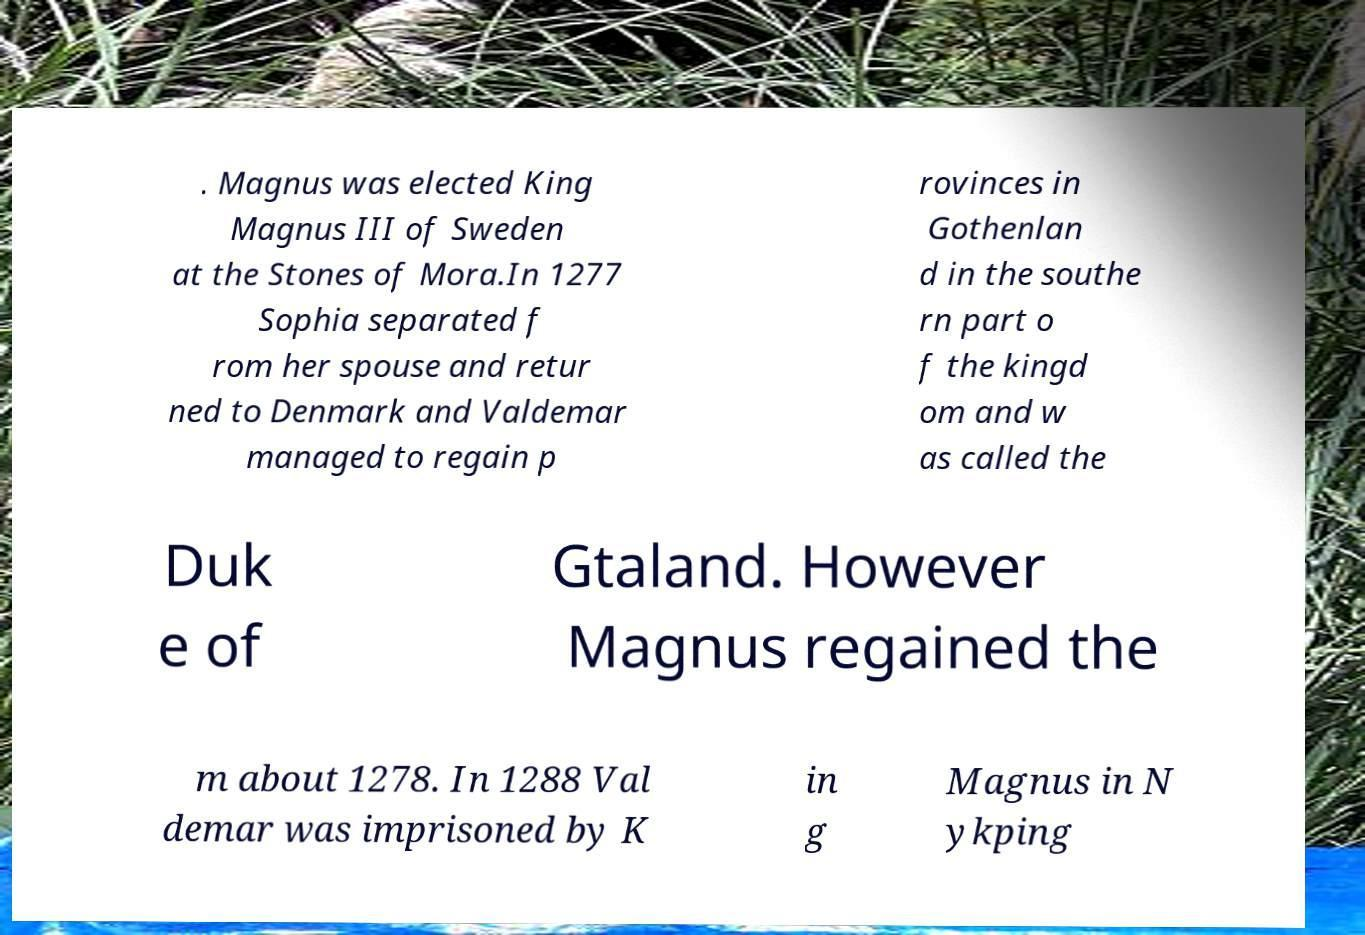Can you read and provide the text displayed in the image?This photo seems to have some interesting text. Can you extract and type it out for me? . Magnus was elected King Magnus III of Sweden at the Stones of Mora.In 1277 Sophia separated f rom her spouse and retur ned to Denmark and Valdemar managed to regain p rovinces in Gothenlan d in the southe rn part o f the kingd om and w as called the Duk e of Gtaland. However Magnus regained the m about 1278. In 1288 Val demar was imprisoned by K in g Magnus in N ykping 